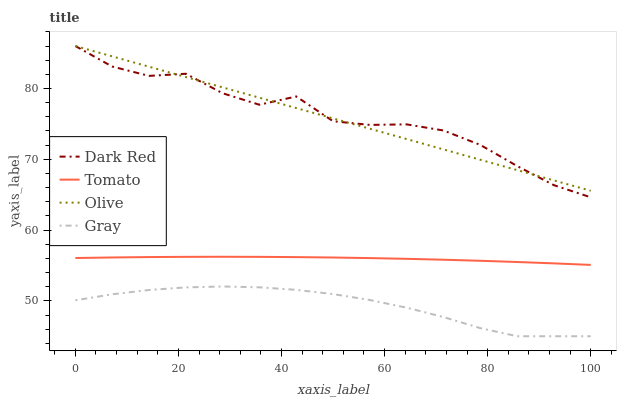Does Gray have the minimum area under the curve?
Answer yes or no. Yes. Does Dark Red have the maximum area under the curve?
Answer yes or no. Yes. Does Dark Red have the minimum area under the curve?
Answer yes or no. No. Does Gray have the maximum area under the curve?
Answer yes or no. No. Is Olive the smoothest?
Answer yes or no. Yes. Is Dark Red the roughest?
Answer yes or no. Yes. Is Gray the smoothest?
Answer yes or no. No. Is Gray the roughest?
Answer yes or no. No. Does Gray have the lowest value?
Answer yes or no. Yes. Does Dark Red have the lowest value?
Answer yes or no. No. Does Olive have the highest value?
Answer yes or no. Yes. Does Gray have the highest value?
Answer yes or no. No. Is Gray less than Tomato?
Answer yes or no. Yes. Is Olive greater than Tomato?
Answer yes or no. Yes. Does Olive intersect Dark Red?
Answer yes or no. Yes. Is Olive less than Dark Red?
Answer yes or no. No. Is Olive greater than Dark Red?
Answer yes or no. No. Does Gray intersect Tomato?
Answer yes or no. No. 